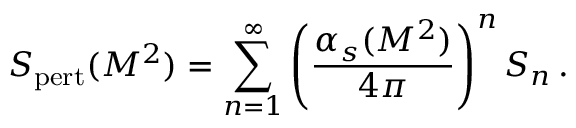Convert formula to latex. <formula><loc_0><loc_0><loc_500><loc_500>S _ { p e r t } ( M ^ { 2 } ) = \sum _ { n = 1 } ^ { \infty } \left ( { \frac { \alpha _ { s } ( M ^ { 2 } ) } { 4 \pi } } \right ) ^ { n } \, S _ { n } \, .</formula> 